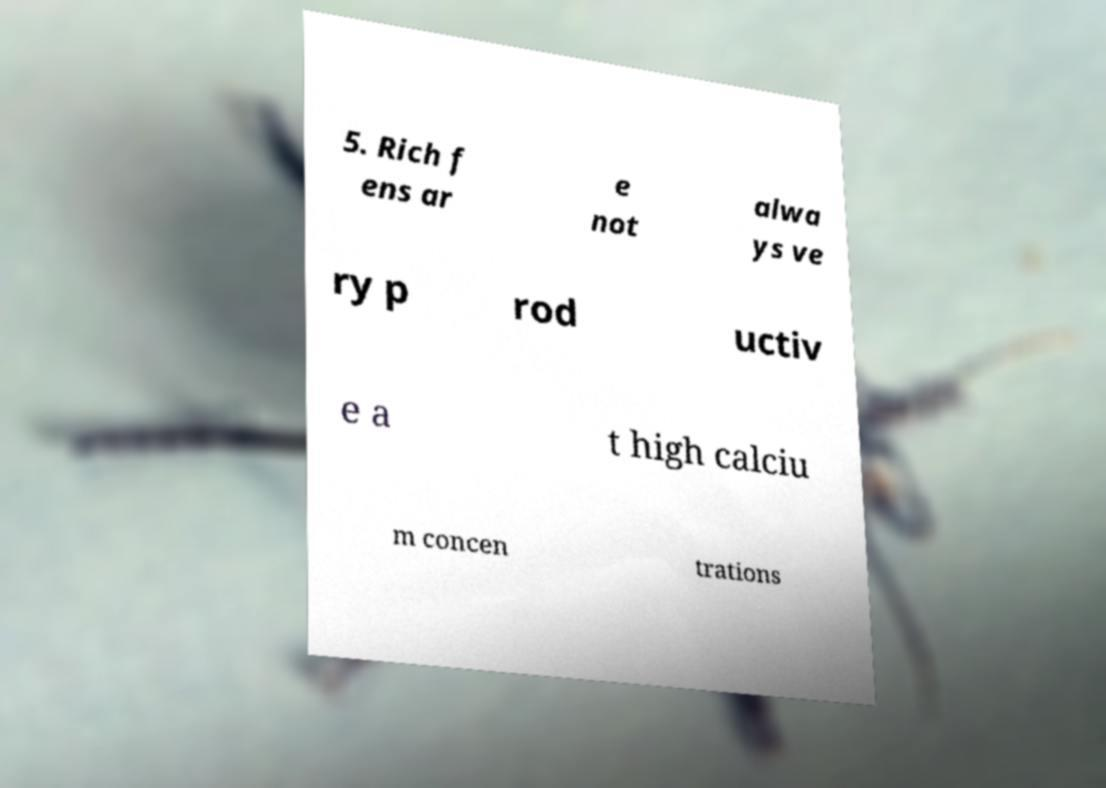Could you assist in decoding the text presented in this image and type it out clearly? 5. Rich f ens ar e not alwa ys ve ry p rod uctiv e a t high calciu m concen trations 